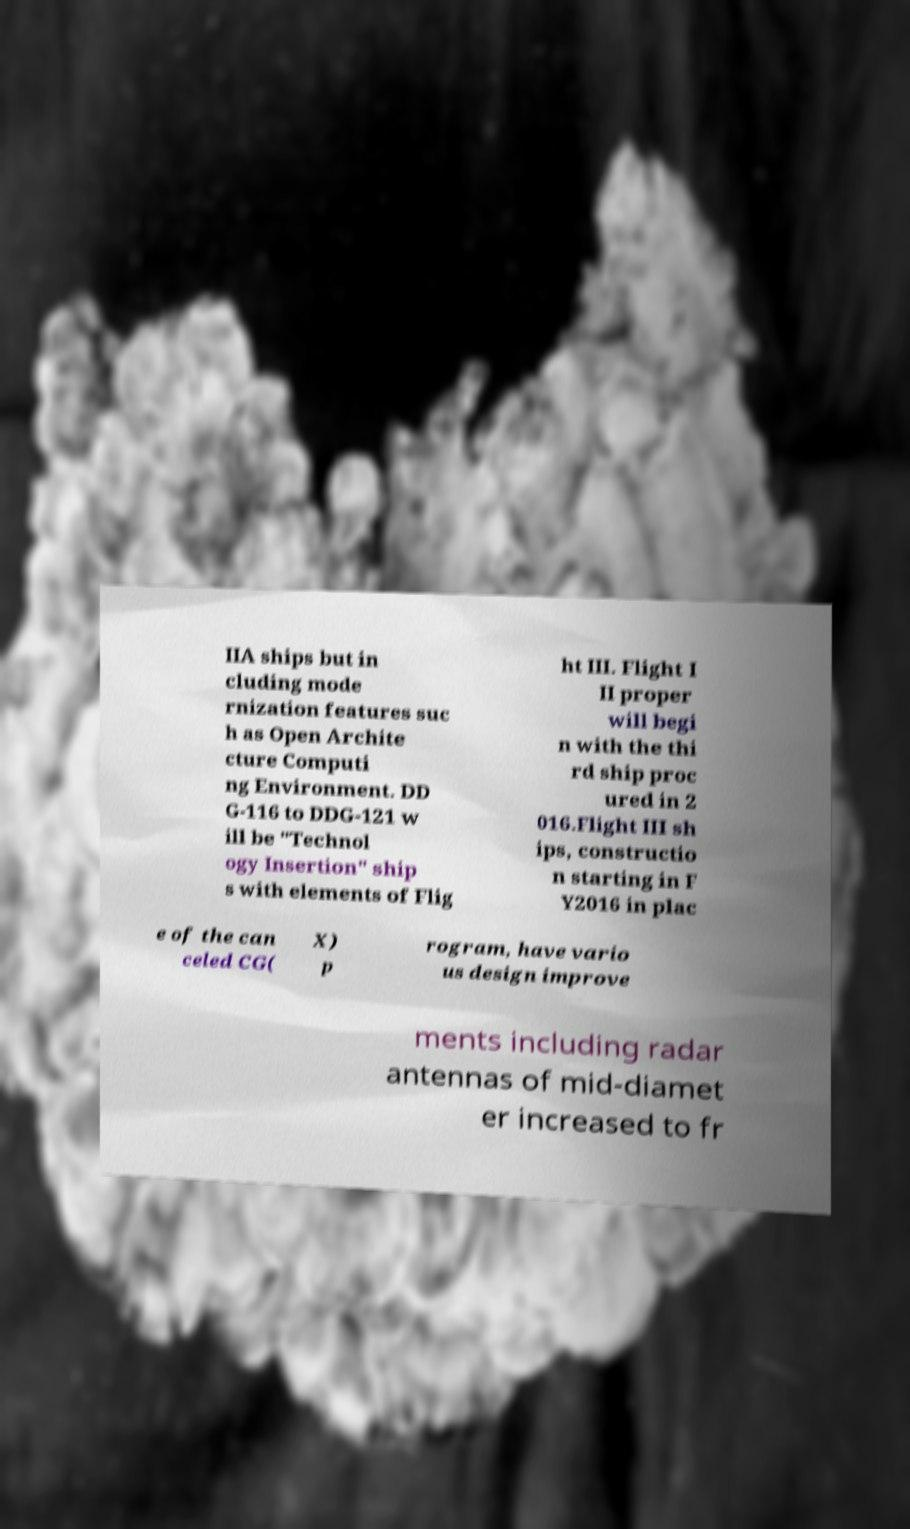For documentation purposes, I need the text within this image transcribed. Could you provide that? IIA ships but in cluding mode rnization features suc h as Open Archite cture Computi ng Environment. DD G-116 to DDG-121 w ill be "Technol ogy Insertion" ship s with elements of Flig ht III. Flight I II proper will begi n with the thi rd ship proc ured in 2 016.Flight III sh ips, constructio n starting in F Y2016 in plac e of the can celed CG( X) p rogram, have vario us design improve ments including radar antennas of mid-diamet er increased to fr 